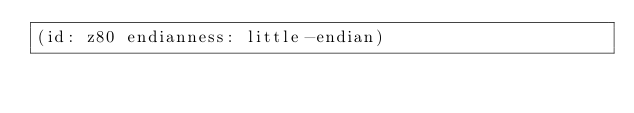<code> <loc_0><loc_0><loc_500><loc_500><_Scheme_>(id: z80 endianness: little-endian)
</code> 